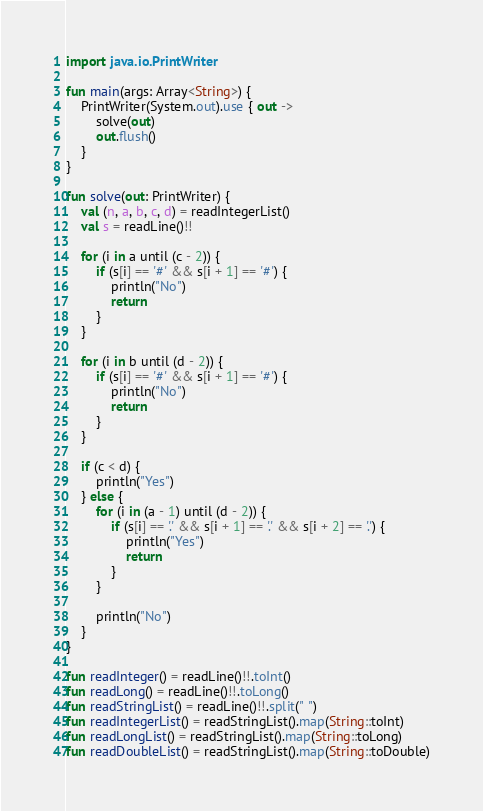<code> <loc_0><loc_0><loc_500><loc_500><_Kotlin_>import java.io.PrintWriter

fun main(args: Array<String>) {
    PrintWriter(System.out).use { out ->
        solve(out)
        out.flush()
    }
}

fun solve(out: PrintWriter) {
    val (n, a, b, c, d) = readIntegerList()
    val s = readLine()!!

    for (i in a until (c - 2)) {
        if (s[i] == '#' && s[i + 1] == '#') {
            println("No")
            return
        }
    }

    for (i in b until (d - 2)) {
        if (s[i] == '#' && s[i + 1] == '#') {
            println("No")
            return
        }
    }

    if (c < d) {
        println("Yes")
    } else {
        for (i in (a - 1) until (d - 2)) {
            if (s[i] == '.' && s[i + 1] == '.' && s[i + 2] == '.') {
                println("Yes")
                return
            }
        }

        println("No")
    }
}

fun readInteger() = readLine()!!.toInt()
fun readLong() = readLine()!!.toLong()
fun readStringList() = readLine()!!.split(" ")
fun readIntegerList() = readStringList().map(String::toInt)
fun readLongList() = readStringList().map(String::toLong)
fun readDoubleList() = readStringList().map(String::toDouble)
</code> 